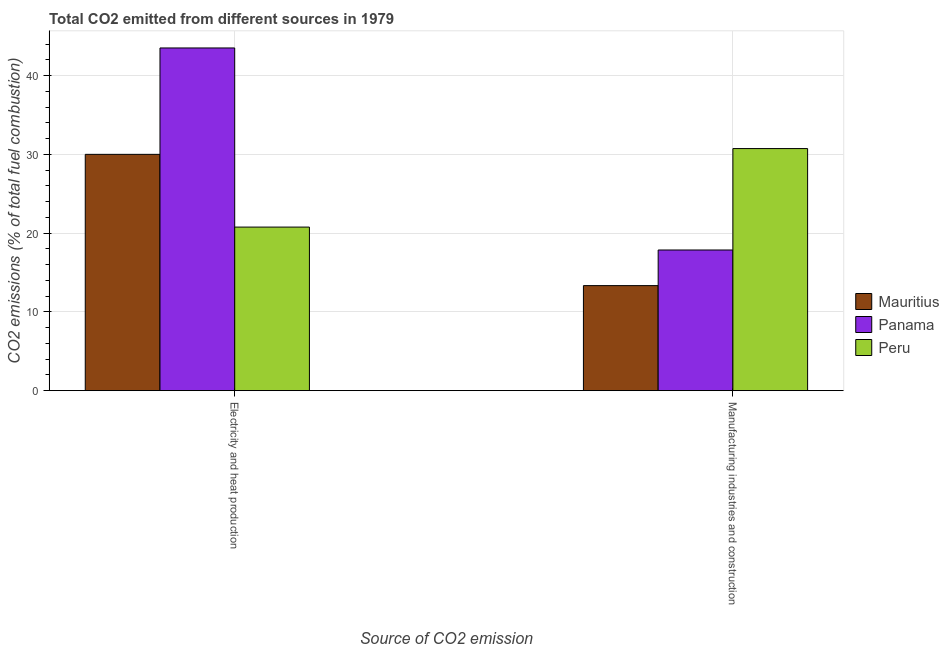How many different coloured bars are there?
Ensure brevity in your answer.  3. How many groups of bars are there?
Provide a succinct answer. 2. Are the number of bars on each tick of the X-axis equal?
Provide a succinct answer. Yes. How many bars are there on the 1st tick from the right?
Your answer should be very brief. 3. What is the label of the 2nd group of bars from the left?
Your answer should be compact. Manufacturing industries and construction. What is the co2 emissions due to manufacturing industries in Mauritius?
Provide a short and direct response. 13.33. Across all countries, what is the maximum co2 emissions due to manufacturing industries?
Provide a short and direct response. 30.73. Across all countries, what is the minimum co2 emissions due to manufacturing industries?
Offer a very short reply. 13.33. In which country was the co2 emissions due to electricity and heat production minimum?
Make the answer very short. Peru. What is the total co2 emissions due to manufacturing industries in the graph?
Offer a terse response. 61.92. What is the difference between the co2 emissions due to manufacturing industries in Mauritius and that in Panama?
Offer a terse response. -4.52. What is the difference between the co2 emissions due to manufacturing industries in Mauritius and the co2 emissions due to electricity and heat production in Panama?
Provide a short and direct response. -30.17. What is the average co2 emissions due to manufacturing industries per country?
Keep it short and to the point. 20.64. What is the difference between the co2 emissions due to manufacturing industries and co2 emissions due to electricity and heat production in Mauritius?
Your answer should be compact. -16.67. What is the ratio of the co2 emissions due to manufacturing industries in Mauritius to that in Peru?
Provide a succinct answer. 0.43. In how many countries, is the co2 emissions due to manufacturing industries greater than the average co2 emissions due to manufacturing industries taken over all countries?
Keep it short and to the point. 1. What does the 3rd bar from the left in Electricity and heat production represents?
Your answer should be compact. Peru. What does the 3rd bar from the right in Manufacturing industries and construction represents?
Provide a succinct answer. Mauritius. How many countries are there in the graph?
Your answer should be compact. 3. Are the values on the major ticks of Y-axis written in scientific E-notation?
Keep it short and to the point. No. Does the graph contain any zero values?
Your response must be concise. No. Does the graph contain grids?
Provide a succinct answer. Yes. What is the title of the graph?
Provide a short and direct response. Total CO2 emitted from different sources in 1979. Does "Cabo Verde" appear as one of the legend labels in the graph?
Your response must be concise. No. What is the label or title of the X-axis?
Give a very brief answer. Source of CO2 emission. What is the label or title of the Y-axis?
Your answer should be compact. CO2 emissions (% of total fuel combustion). What is the CO2 emissions (% of total fuel combustion) in Panama in Electricity and heat production?
Give a very brief answer. 43.51. What is the CO2 emissions (% of total fuel combustion) in Peru in Electricity and heat production?
Your answer should be compact. 20.76. What is the CO2 emissions (% of total fuel combustion) of Mauritius in Manufacturing industries and construction?
Make the answer very short. 13.33. What is the CO2 emissions (% of total fuel combustion) in Panama in Manufacturing industries and construction?
Keep it short and to the point. 17.86. What is the CO2 emissions (% of total fuel combustion) in Peru in Manufacturing industries and construction?
Keep it short and to the point. 30.73. Across all Source of CO2 emission, what is the maximum CO2 emissions (% of total fuel combustion) of Mauritius?
Provide a short and direct response. 30. Across all Source of CO2 emission, what is the maximum CO2 emissions (% of total fuel combustion) in Panama?
Give a very brief answer. 43.51. Across all Source of CO2 emission, what is the maximum CO2 emissions (% of total fuel combustion) of Peru?
Ensure brevity in your answer.  30.73. Across all Source of CO2 emission, what is the minimum CO2 emissions (% of total fuel combustion) in Mauritius?
Provide a succinct answer. 13.33. Across all Source of CO2 emission, what is the minimum CO2 emissions (% of total fuel combustion) in Panama?
Your response must be concise. 17.86. Across all Source of CO2 emission, what is the minimum CO2 emissions (% of total fuel combustion) of Peru?
Provide a short and direct response. 20.76. What is the total CO2 emissions (% of total fuel combustion) in Mauritius in the graph?
Ensure brevity in your answer.  43.33. What is the total CO2 emissions (% of total fuel combustion) in Panama in the graph?
Provide a succinct answer. 61.36. What is the total CO2 emissions (% of total fuel combustion) in Peru in the graph?
Ensure brevity in your answer.  51.5. What is the difference between the CO2 emissions (% of total fuel combustion) of Mauritius in Electricity and heat production and that in Manufacturing industries and construction?
Your response must be concise. 16.67. What is the difference between the CO2 emissions (% of total fuel combustion) of Panama in Electricity and heat production and that in Manufacturing industries and construction?
Your answer should be very brief. 25.65. What is the difference between the CO2 emissions (% of total fuel combustion) of Peru in Electricity and heat production and that in Manufacturing industries and construction?
Ensure brevity in your answer.  -9.97. What is the difference between the CO2 emissions (% of total fuel combustion) of Mauritius in Electricity and heat production and the CO2 emissions (% of total fuel combustion) of Panama in Manufacturing industries and construction?
Provide a succinct answer. 12.14. What is the difference between the CO2 emissions (% of total fuel combustion) of Mauritius in Electricity and heat production and the CO2 emissions (% of total fuel combustion) of Peru in Manufacturing industries and construction?
Your answer should be compact. -0.73. What is the difference between the CO2 emissions (% of total fuel combustion) of Panama in Electricity and heat production and the CO2 emissions (% of total fuel combustion) of Peru in Manufacturing industries and construction?
Ensure brevity in your answer.  12.77. What is the average CO2 emissions (% of total fuel combustion) of Mauritius per Source of CO2 emission?
Keep it short and to the point. 21.67. What is the average CO2 emissions (% of total fuel combustion) in Panama per Source of CO2 emission?
Make the answer very short. 30.68. What is the average CO2 emissions (% of total fuel combustion) in Peru per Source of CO2 emission?
Offer a very short reply. 25.75. What is the difference between the CO2 emissions (% of total fuel combustion) in Mauritius and CO2 emissions (% of total fuel combustion) in Panama in Electricity and heat production?
Offer a very short reply. -13.51. What is the difference between the CO2 emissions (% of total fuel combustion) in Mauritius and CO2 emissions (% of total fuel combustion) in Peru in Electricity and heat production?
Offer a terse response. 9.24. What is the difference between the CO2 emissions (% of total fuel combustion) in Panama and CO2 emissions (% of total fuel combustion) in Peru in Electricity and heat production?
Offer a very short reply. 22.74. What is the difference between the CO2 emissions (% of total fuel combustion) in Mauritius and CO2 emissions (% of total fuel combustion) in Panama in Manufacturing industries and construction?
Give a very brief answer. -4.52. What is the difference between the CO2 emissions (% of total fuel combustion) of Mauritius and CO2 emissions (% of total fuel combustion) of Peru in Manufacturing industries and construction?
Ensure brevity in your answer.  -17.4. What is the difference between the CO2 emissions (% of total fuel combustion) in Panama and CO2 emissions (% of total fuel combustion) in Peru in Manufacturing industries and construction?
Ensure brevity in your answer.  -12.88. What is the ratio of the CO2 emissions (% of total fuel combustion) in Mauritius in Electricity and heat production to that in Manufacturing industries and construction?
Your response must be concise. 2.25. What is the ratio of the CO2 emissions (% of total fuel combustion) in Panama in Electricity and heat production to that in Manufacturing industries and construction?
Your answer should be compact. 2.44. What is the ratio of the CO2 emissions (% of total fuel combustion) in Peru in Electricity and heat production to that in Manufacturing industries and construction?
Ensure brevity in your answer.  0.68. What is the difference between the highest and the second highest CO2 emissions (% of total fuel combustion) in Mauritius?
Make the answer very short. 16.67. What is the difference between the highest and the second highest CO2 emissions (% of total fuel combustion) in Panama?
Provide a short and direct response. 25.65. What is the difference between the highest and the second highest CO2 emissions (% of total fuel combustion) of Peru?
Keep it short and to the point. 9.97. What is the difference between the highest and the lowest CO2 emissions (% of total fuel combustion) in Mauritius?
Provide a short and direct response. 16.67. What is the difference between the highest and the lowest CO2 emissions (% of total fuel combustion) in Panama?
Ensure brevity in your answer.  25.65. What is the difference between the highest and the lowest CO2 emissions (% of total fuel combustion) in Peru?
Your answer should be very brief. 9.97. 